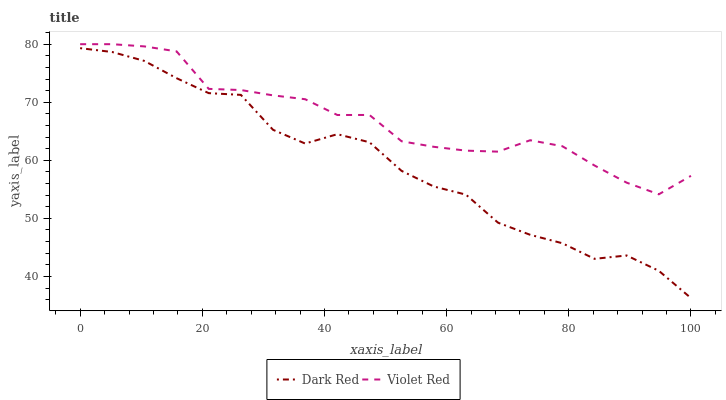Does Dark Red have the minimum area under the curve?
Answer yes or no. Yes. Does Violet Red have the maximum area under the curve?
Answer yes or no. Yes. Does Violet Red have the minimum area under the curve?
Answer yes or no. No. Is Violet Red the smoothest?
Answer yes or no. Yes. Is Dark Red the roughest?
Answer yes or no. Yes. Is Violet Red the roughest?
Answer yes or no. No. Does Violet Red have the lowest value?
Answer yes or no. No. Does Violet Red have the highest value?
Answer yes or no. Yes. Is Dark Red less than Violet Red?
Answer yes or no. Yes. Is Violet Red greater than Dark Red?
Answer yes or no. Yes. Does Dark Red intersect Violet Red?
Answer yes or no. No. 